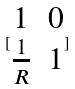Convert formula to latex. <formula><loc_0><loc_0><loc_500><loc_500>[ \begin{matrix} 1 & 0 \\ \frac { 1 } { R } & 1 \end{matrix} ]</formula> 